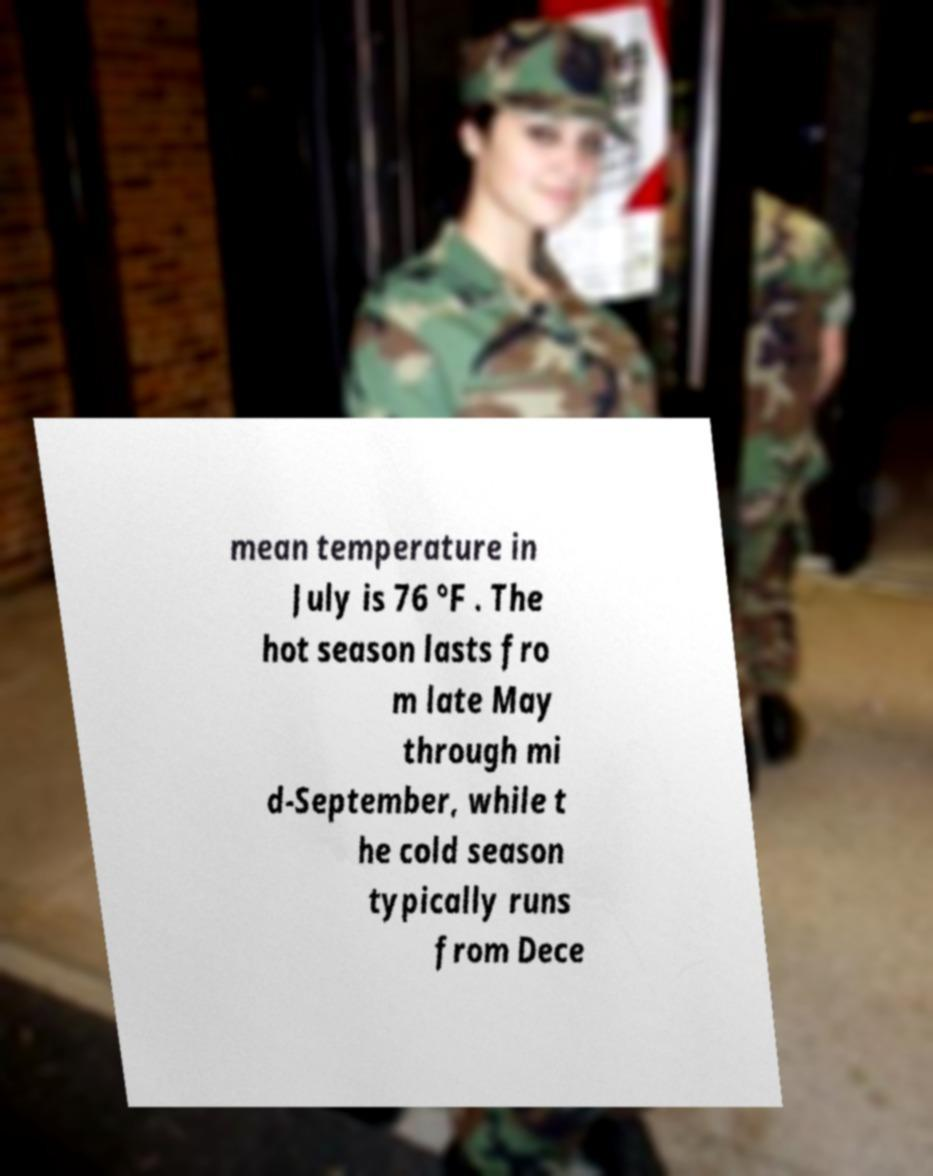What messages or text are displayed in this image? I need them in a readable, typed format. mean temperature in July is 76 °F . The hot season lasts fro m late May through mi d-September, while t he cold season typically runs from Dece 